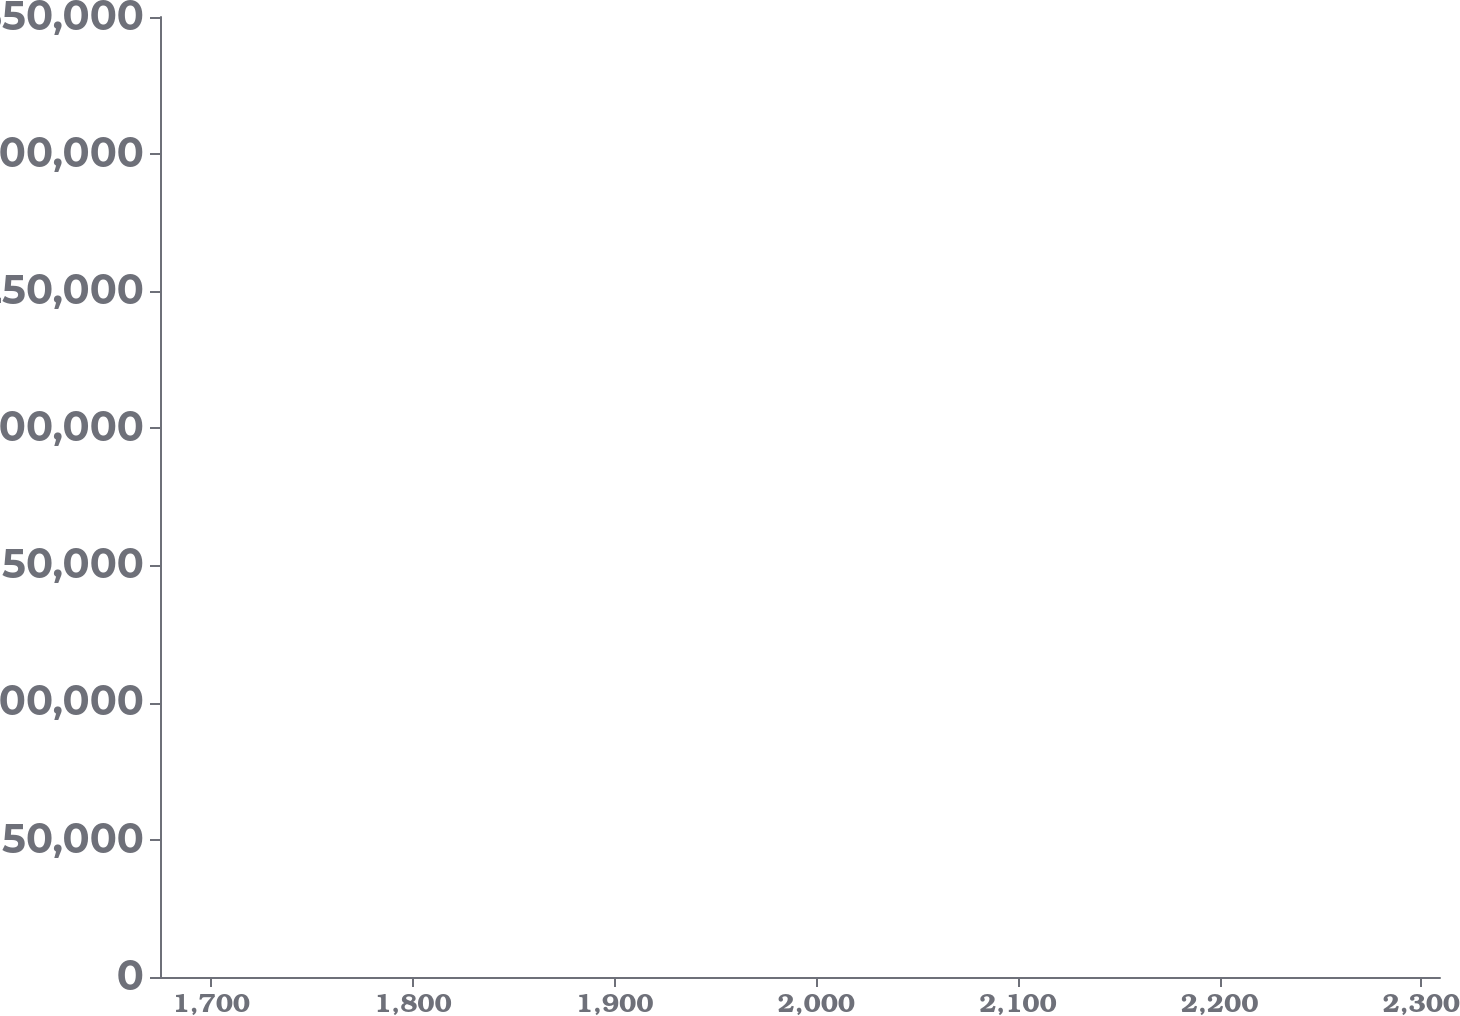Convert chart to OTSL. <chart><loc_0><loc_0><loc_500><loc_500><line_chart><ecel><fcel>(in thousands)<nl><fcel>1738.05<fcel>200822<nl><fcel>1831.14<fcel>235838<nl><fcel>1934.11<fcel>129279<nl><fcel>1997.58<fcel>341611<nl><fcel>2372.78<fcel>479438<nl></chart> 